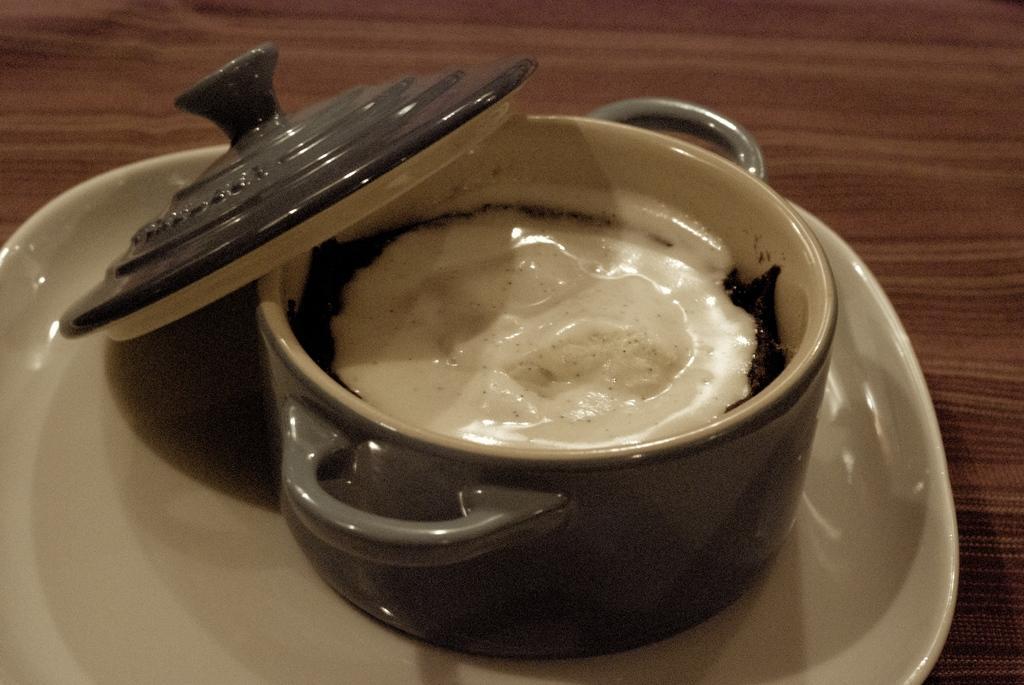Describe this image in one or two sentences. In this image I see the cream color plate on which there is a utensil which is of cream and brown in color and I see the lid and I see the food in it which is of white and black in color and this plate is on the brown color surface. 